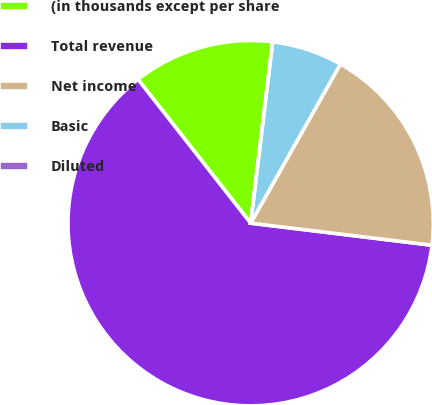Convert chart. <chart><loc_0><loc_0><loc_500><loc_500><pie_chart><fcel>(in thousands except per share<fcel>Total revenue<fcel>Net income<fcel>Basic<fcel>Diluted<nl><fcel>12.5%<fcel>62.5%<fcel>18.75%<fcel>6.25%<fcel>0.0%<nl></chart> 